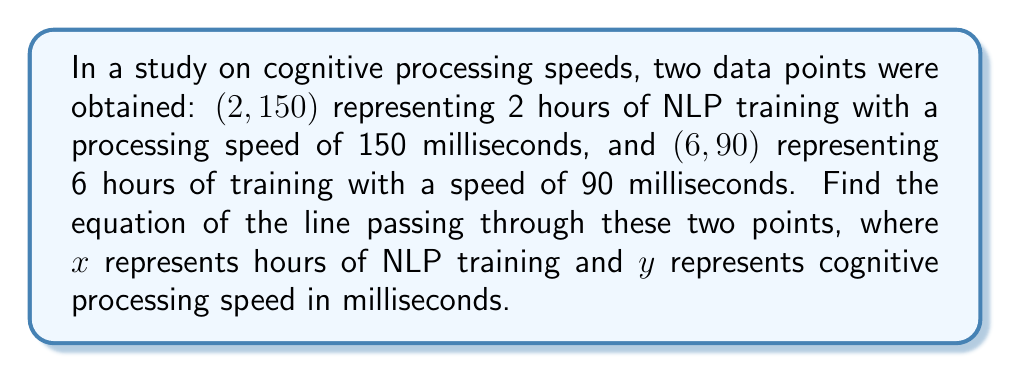Help me with this question. To find the equation of a line passing through two points, we can use the point-slope form of a line: $y - y_1 = m(x - x_1)$, where $m$ is the slope.

Step 1: Calculate the slope $(m)$ using the two given points.
$m = \frac{y_2 - y_1}{x_2 - x_1} = \frac{90 - 150}{6 - 2} = \frac{-60}{4} = -15$

Step 2: Use either point and the calculated slope in the point-slope form.
Let's use $(2, 150)$:
$y - 150 = -15(x - 2)$

Step 3: Distribute the slope:
$y - 150 = -15x + 30$

Step 4: Add 150 to both sides to isolate $y$:
$y = -15x + 30 + 150$

Step 5: Simplify:
$y = -15x + 180$

This equation represents the line passing through the two given points, where $x$ is the number of hours of NLP training and $y$ is the cognitive processing speed in milliseconds.
Answer: $y = -15x + 180$ 